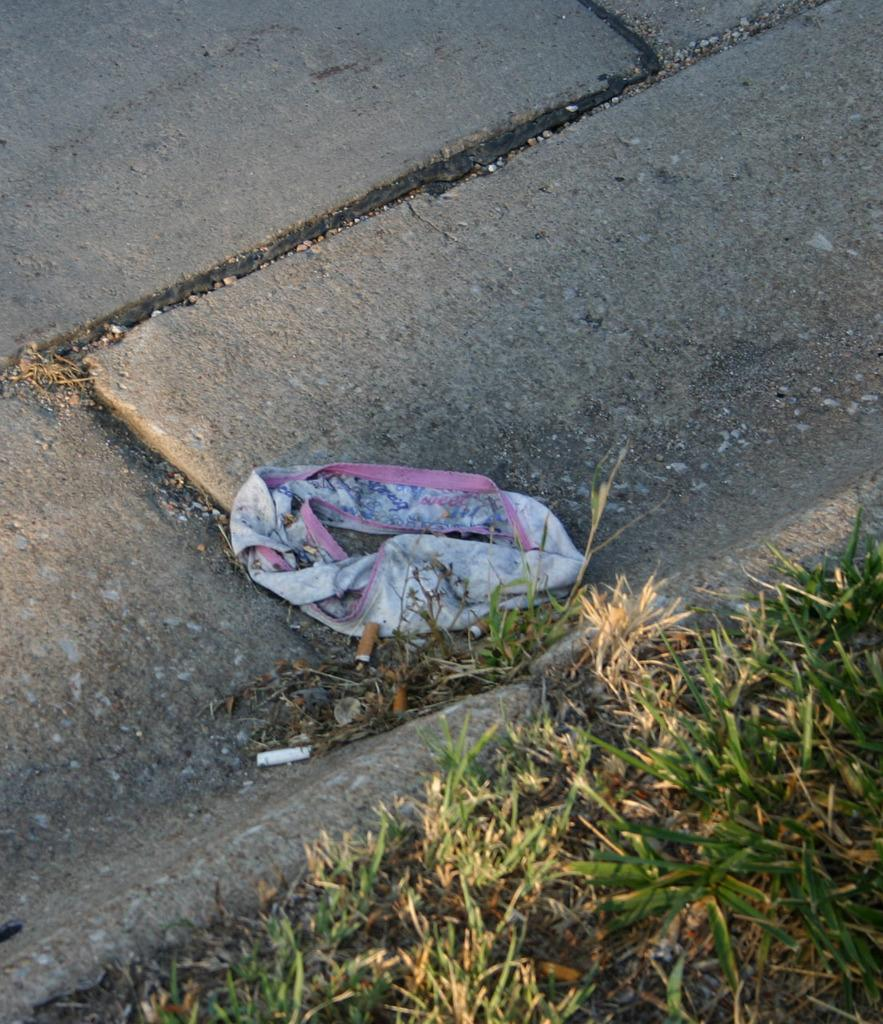What is on the road in the image? There is a cloth on the road in the image. What type of vegetation can be seen on the ground in the image? There is green grass on the ground in the image. What type of litter is present on the ground in the image? Cigarette butts are present on the ground in the image. How many spoons can be seen in the image? There are no spoons present in the image. Does the existence of the cloth on the road prove the existence of a supernatural being in the image? The presence of the cloth on the road does not prove the existence of a supernatural being in the image. 